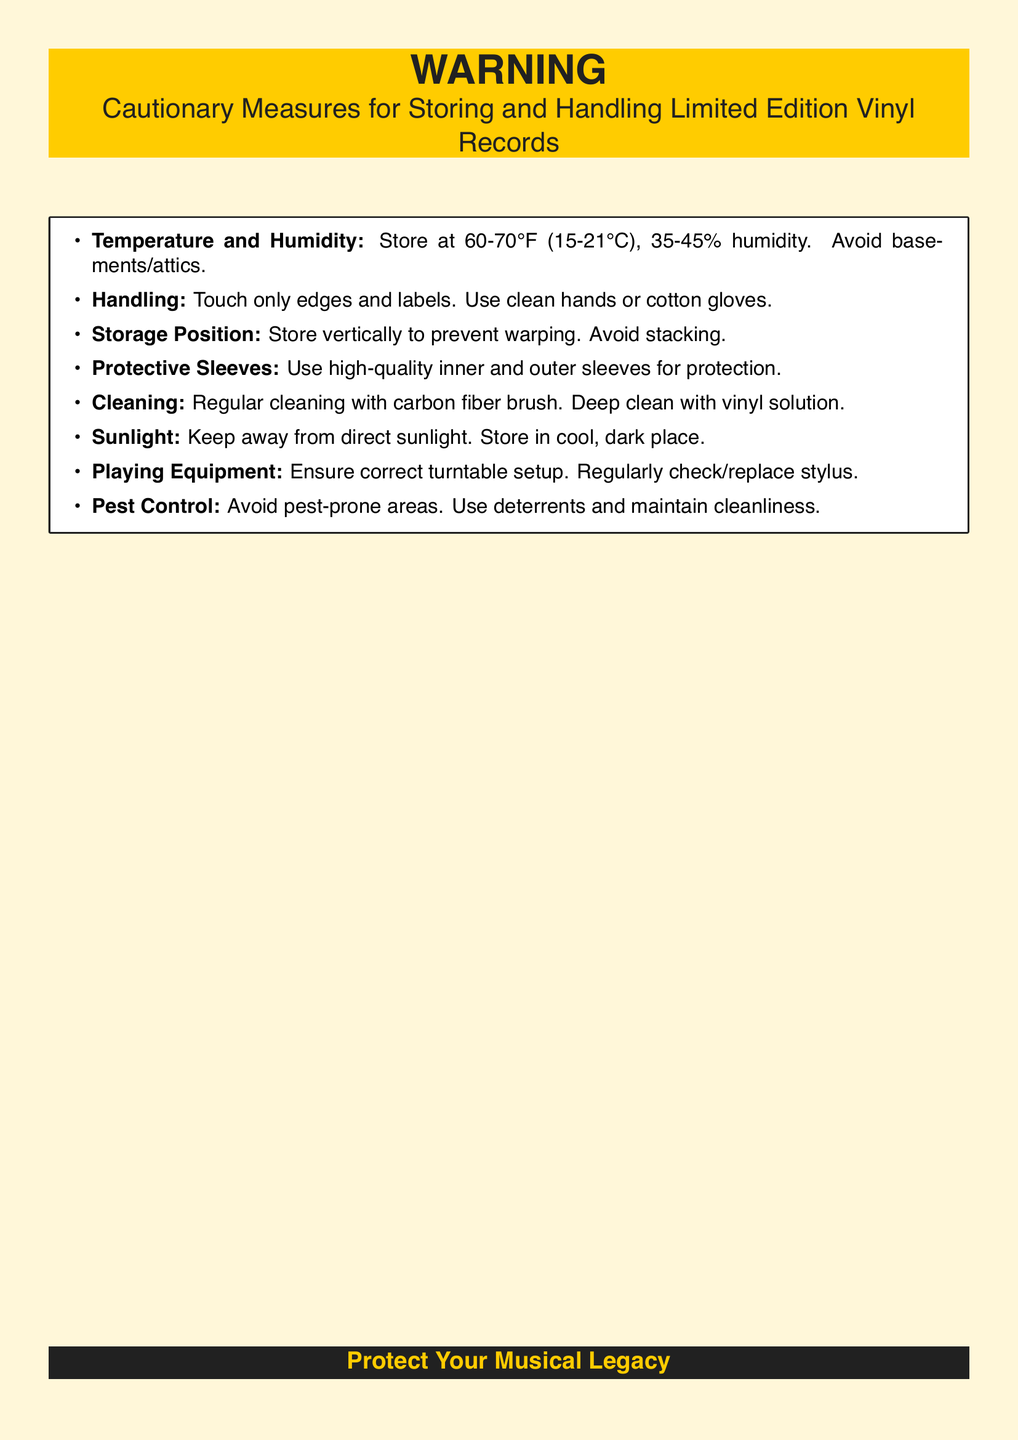What is the recommended temperature range for storing vinyl records? The document specifies that vinyl records should be stored at a temperature of 60-70°F (15-21°C).
Answer: 60-70°F (15-21°C) What is the ideal humidity range for vinyl record storage? The document states that the ideal humidity range is 35-45%.
Answer: 35-45% What should you use to handle vinyl records? The handling guidelines suggest using clean hands or cotton gloves.
Answer: Clean hands or cotton gloves What position should vinyl records be stored in? The document advises that vinyl records should be stored vertically.
Answer: Vertically What type of sleeves should be used for vinyl records? The warning label recommends using high-quality inner and outer sleeves.
Answer: High-quality inner and outer sleeves What should be avoided to prevent warping of vinyl records? The document states that stacking records should be avoided to prevent warping.
Answer: Stacking What is the preferred way to clean vinyl records? The document suggests regular cleaning with a carbon fiber brush.
Answer: Carbon fiber brush Why should vinyl records be kept away from direct sunlight? The warning label indicates that direct sunlight can damage the records, so they should be stored in a cool, dark place.
Answer: Damage What equipment should be checked regularly for playing vinyl records? The document mentions that the turntable setup and stylus should be regularly checked and replaced.
Answer: Turntable setup and stylus Where should vinyl records not be stored? According to the document, basements and attics should be avoided for storage.
Answer: Basements and attics 